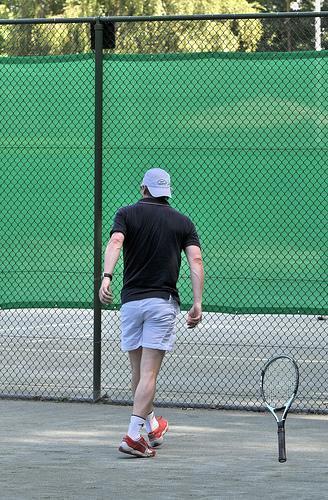How many horses are there in the photo?
Give a very brief answer. 0. 